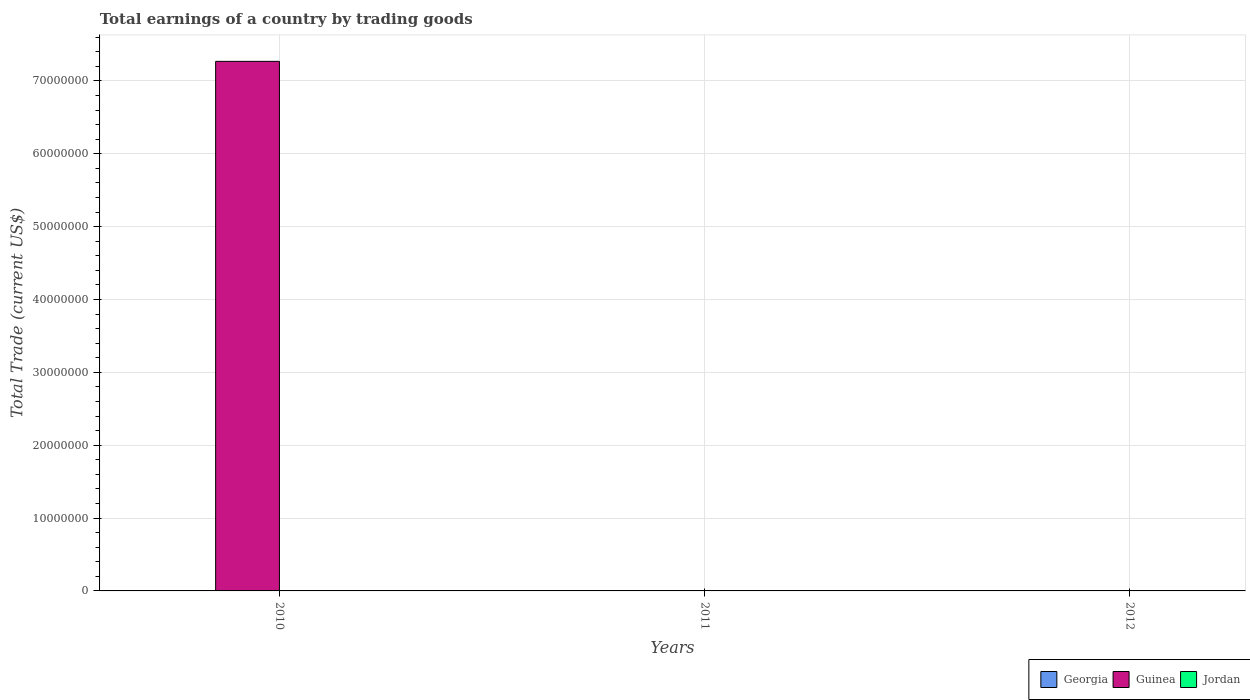How many different coloured bars are there?
Offer a very short reply. 1. How many bars are there on the 2nd tick from the left?
Make the answer very short. 0. Across all years, what is the maximum total earnings in Guinea?
Provide a short and direct response. 7.27e+07. Across all years, what is the minimum total earnings in Georgia?
Your answer should be very brief. 0. In which year was the total earnings in Guinea maximum?
Provide a short and direct response. 2010. What is the total total earnings in Guinea in the graph?
Offer a terse response. 7.27e+07. What is the difference between the total earnings in Guinea in 2010 and the total earnings in Jordan in 2012?
Your answer should be very brief. 7.27e+07. What is the difference between the highest and the lowest total earnings in Guinea?
Your answer should be compact. 7.27e+07. In how many years, is the total earnings in Jordan greater than the average total earnings in Jordan taken over all years?
Provide a succinct answer. 0. Are all the bars in the graph horizontal?
Keep it short and to the point. No. How many years are there in the graph?
Your answer should be very brief. 3. Does the graph contain any zero values?
Provide a succinct answer. Yes. Where does the legend appear in the graph?
Offer a very short reply. Bottom right. How are the legend labels stacked?
Ensure brevity in your answer.  Horizontal. What is the title of the graph?
Offer a terse response. Total earnings of a country by trading goods. Does "Syrian Arab Republic" appear as one of the legend labels in the graph?
Keep it short and to the point. No. What is the label or title of the Y-axis?
Ensure brevity in your answer.  Total Trade (current US$). What is the Total Trade (current US$) in Georgia in 2010?
Offer a terse response. 0. What is the Total Trade (current US$) in Guinea in 2010?
Keep it short and to the point. 7.27e+07. What is the Total Trade (current US$) of Jordan in 2010?
Provide a succinct answer. 0. What is the Total Trade (current US$) in Georgia in 2011?
Keep it short and to the point. 0. What is the Total Trade (current US$) in Guinea in 2011?
Offer a terse response. 0. What is the Total Trade (current US$) in Guinea in 2012?
Your answer should be very brief. 0. What is the Total Trade (current US$) in Jordan in 2012?
Give a very brief answer. 0. Across all years, what is the maximum Total Trade (current US$) in Guinea?
Give a very brief answer. 7.27e+07. Across all years, what is the minimum Total Trade (current US$) in Guinea?
Your response must be concise. 0. What is the total Total Trade (current US$) of Georgia in the graph?
Offer a terse response. 0. What is the total Total Trade (current US$) in Guinea in the graph?
Give a very brief answer. 7.27e+07. What is the total Total Trade (current US$) in Jordan in the graph?
Provide a short and direct response. 0. What is the average Total Trade (current US$) of Guinea per year?
Your answer should be very brief. 2.42e+07. What is the difference between the highest and the lowest Total Trade (current US$) of Guinea?
Your answer should be compact. 7.27e+07. 